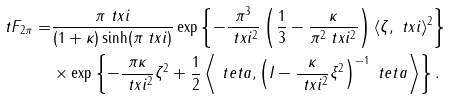Convert formula to latex. <formula><loc_0><loc_0><loc_500><loc_500>\ t F _ { 2 \pi } = & \frac { \pi \| \ t x i \| } { ( 1 + \kappa ) \sinh ( \pi \| \ t x i \| ) } \exp \left \{ - \frac { \pi ^ { 3 } } { \| \ t x i \| ^ { 2 } } \left ( \frac { 1 } { 3 } - \frac { \kappa } { \pi ^ { 2 } \| \ t x i \| ^ { 2 } } \right ) \langle \zeta , \ t x i \rangle ^ { 2 } \right \} \\ & \times \exp \left \{ - \frac { \pi \kappa } { \| \ t x i \| ^ { 2 } } \| \zeta \| ^ { 2 } + \frac { 1 } { 2 } \left \langle \ t e t a , \left ( I - \frac { \kappa } { \| \ t x i \| ^ { 2 } } \xi ^ { 2 } \right ) ^ { - 1 } \ t e t a \right \rangle \right \} .</formula> 